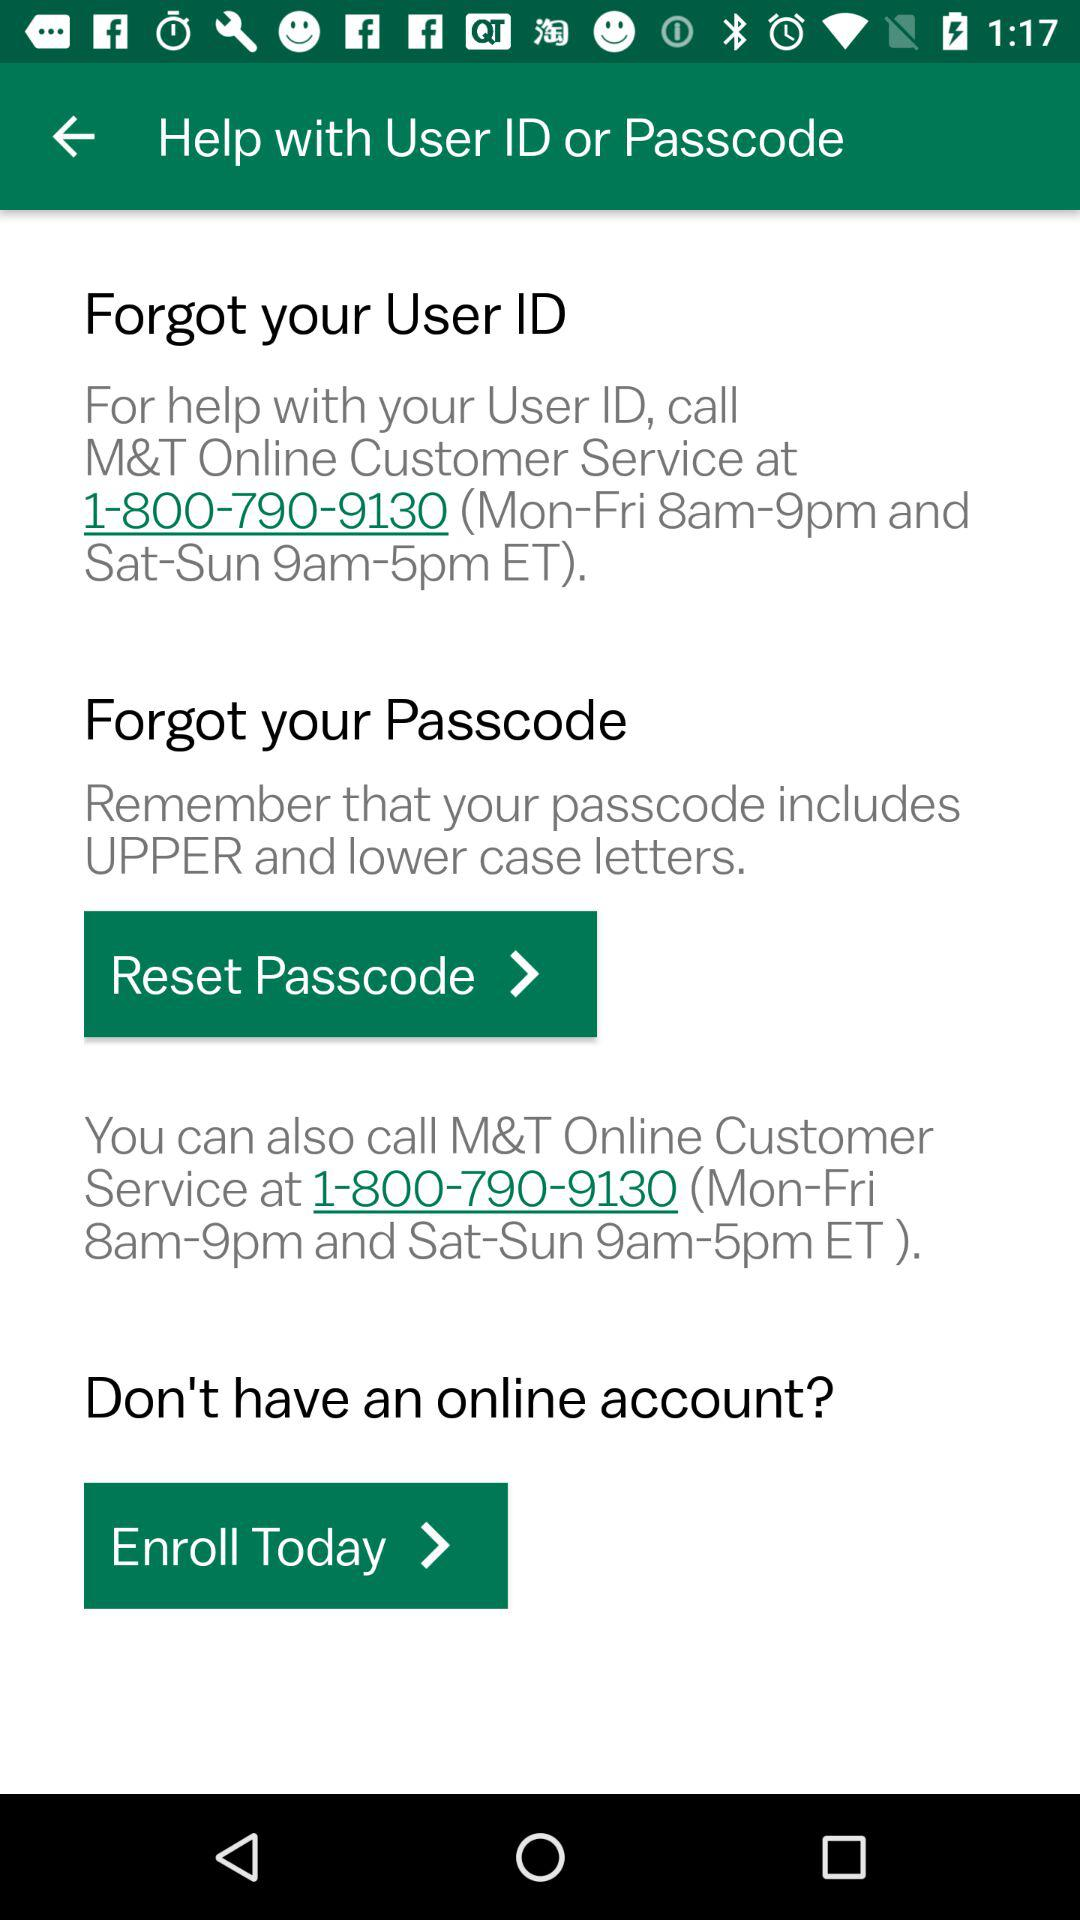What is the company name? The company name is "M&T". 